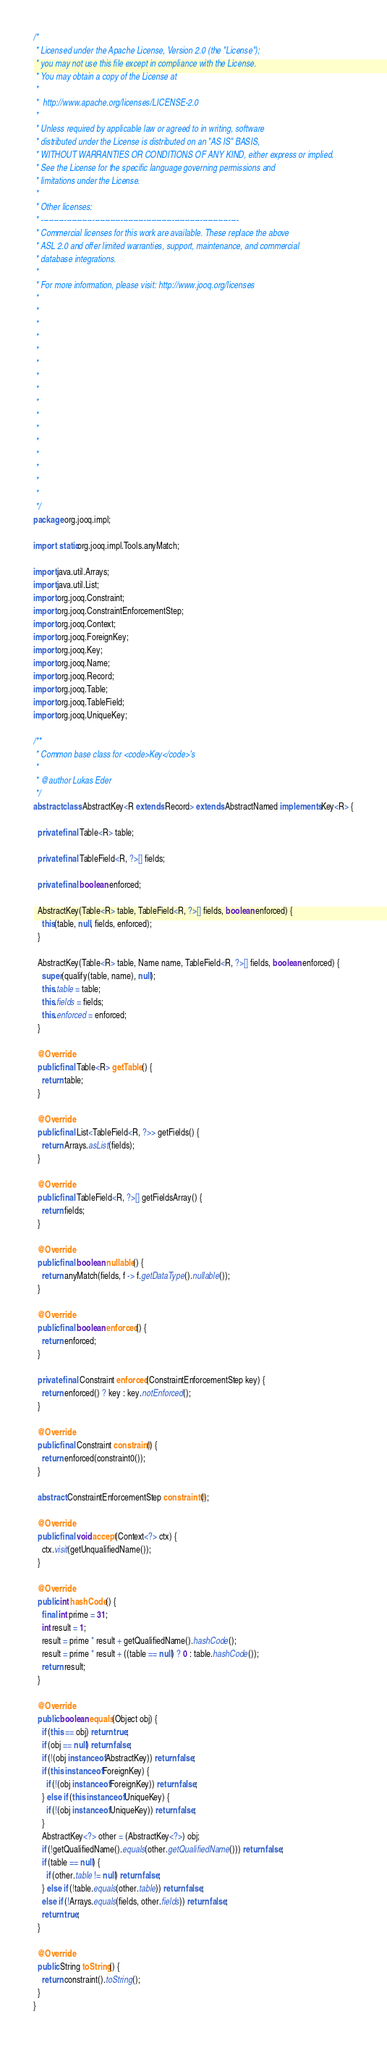<code> <loc_0><loc_0><loc_500><loc_500><_Java_>/* 
 * Licensed under the Apache License, Version 2.0 (the "License");
 * you may not use this file except in compliance with the License.
 * You may obtain a copy of the License at
 *
 *  http://www.apache.org/licenses/LICENSE-2.0
 *
 * Unless required by applicable law or agreed to in writing, software
 * distributed under the License is distributed on an "AS IS" BASIS,
 * WITHOUT WARRANTIES OR CONDITIONS OF ANY KIND, either express or implied.
 * See the License for the specific language governing permissions and
 * limitations under the License.
 *
 * Other licenses:
 * -----------------------------------------------------------------------------
 * Commercial licenses for this work are available. These replace the above
 * ASL 2.0 and offer limited warranties, support, maintenance, and commercial
 * database integrations.
 *
 * For more information, please visit: http://www.jooq.org/licenses
 *
 *
 *
 *
 *
 *
 *
 *
 *
 *
 *
 *
 *
 *
 *
 *
 */
package org.jooq.impl;

import static org.jooq.impl.Tools.anyMatch;

import java.util.Arrays;
import java.util.List;
import org.jooq.Constraint;
import org.jooq.ConstraintEnforcementStep;
import org.jooq.Context;
import org.jooq.ForeignKey;
import org.jooq.Key;
import org.jooq.Name;
import org.jooq.Record;
import org.jooq.Table;
import org.jooq.TableField;
import org.jooq.UniqueKey;

/**
 * Common base class for <code>Key</code>'s
 *
 * @author Lukas Eder
 */
abstract class AbstractKey<R extends Record> extends AbstractNamed implements Key<R> {

  private final Table<R> table;

  private final TableField<R, ?>[] fields;

  private final boolean enforced;

  AbstractKey(Table<R> table, TableField<R, ?>[] fields, boolean enforced) {
    this(table, null, fields, enforced);
  }

  AbstractKey(Table<R> table, Name name, TableField<R, ?>[] fields, boolean enforced) {
    super(qualify(table, name), null);
    this.table = table;
    this.fields = fields;
    this.enforced = enforced;
  }

  @Override
  public final Table<R> getTable() {
    return table;
  }

  @Override
  public final List<TableField<R, ?>> getFields() {
    return Arrays.asList(fields);
  }

  @Override
  public final TableField<R, ?>[] getFieldsArray() {
    return fields;
  }

  @Override
  public final boolean nullable() {
    return anyMatch(fields, f -> f.getDataType().nullable());
  }

  @Override
  public final boolean enforced() {
    return enforced;
  }

  private final Constraint enforced(ConstraintEnforcementStep key) {
    return enforced() ? key : key.notEnforced();
  }

  @Override
  public final Constraint constraint() {
    return enforced(constraint0());
  }

  abstract ConstraintEnforcementStep constraint0();

  @Override
  public final void accept(Context<?> ctx) {
    ctx.visit(getUnqualifiedName());
  }

  @Override
  public int hashCode() {
    final int prime = 31;
    int result = 1;
    result = prime * result + getQualifiedName().hashCode();
    result = prime * result + ((table == null) ? 0 : table.hashCode());
    return result;
  }

  @Override
  public boolean equals(Object obj) {
    if (this == obj) return true;
    if (obj == null) return false;
    if (!(obj instanceof AbstractKey)) return false;
    if (this instanceof ForeignKey) {
      if (!(obj instanceof ForeignKey)) return false;
    } else if (this instanceof UniqueKey) {
      if (!(obj instanceof UniqueKey)) return false;
    }
    AbstractKey<?> other = (AbstractKey<?>) obj;
    if (!getQualifiedName().equals(other.getQualifiedName())) return false;
    if (table == null) {
      if (other.table != null) return false;
    } else if (!table.equals(other.table)) return false;
    else if (!Arrays.equals(fields, other.fields)) return false;
    return true;
  }

  @Override
  public String toString() {
    return constraint().toString();
  }
}
</code> 